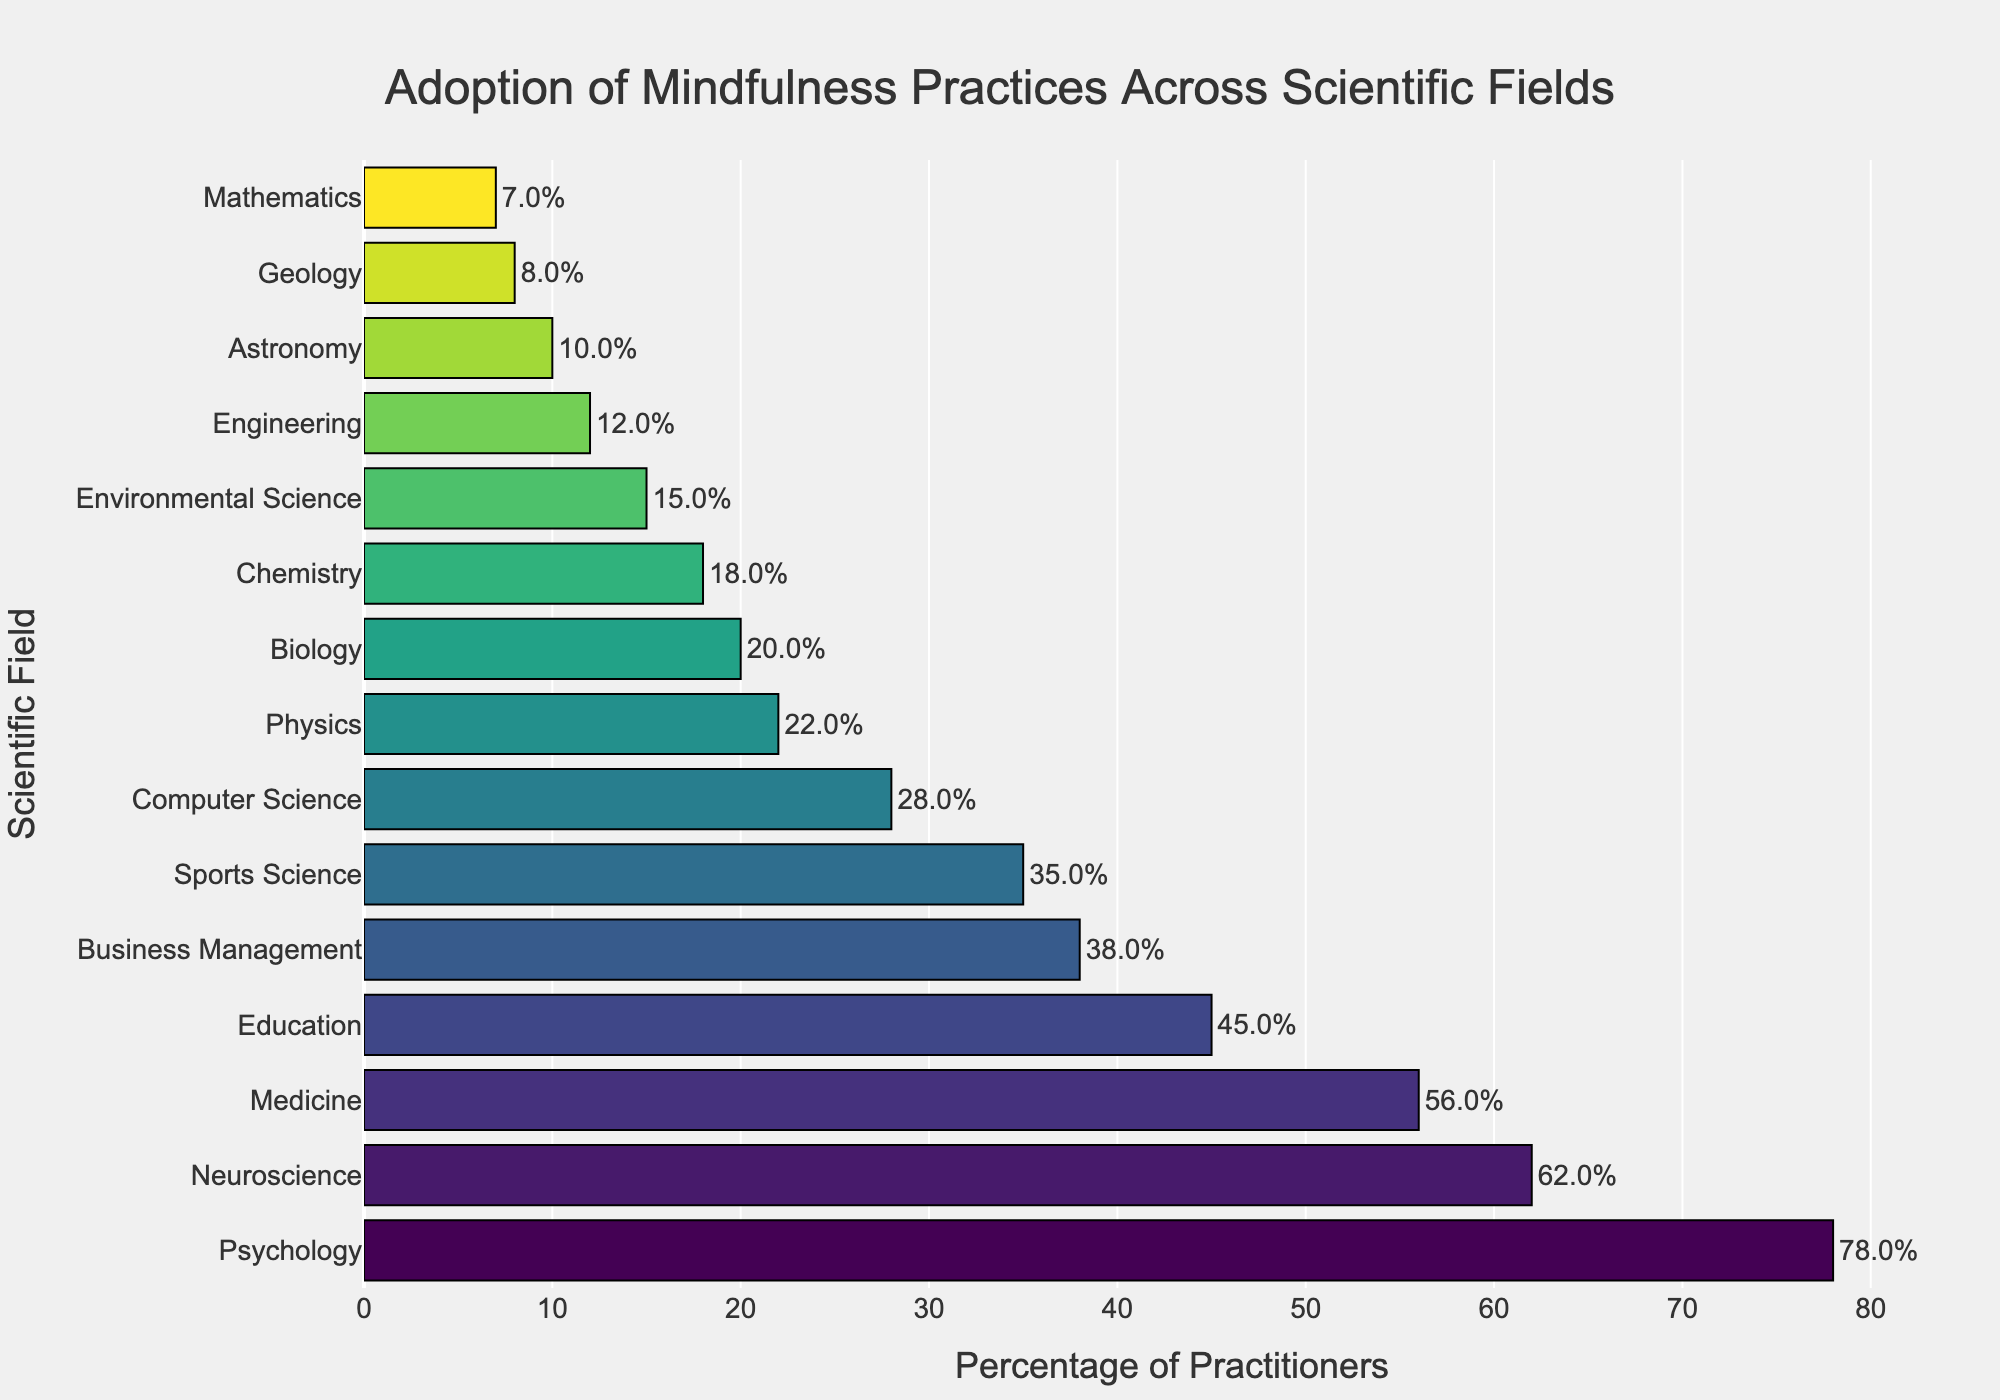Which scientific field has the highest percentage of practitioners adopting mindfulness practices? The field with the tallest bar to the right in the bar chart represents the scientific field with the highest percentage of mindfulness practitioners. In this case, the tallest bar corresponds to Psychology.
Answer: Psychology Which two fields have similar percentages of mindfulness practitioners, according to the bar chart? Fields with bars of almost equal length have similar percentages of practitioners. Sports Science (35%) and Business Management (38%) have similar percentages.
Answer: Sports Science and Business Management How many more practitioners adopt mindfulness in Medicine compared to Engineering? To find the difference, look at the lengths of the bars for Medicine and Engineering. Medicine has 56%, and Engineering has 12%. Subtract Engineering's percentage from Medicine's: 56% - 12%.
Answer: 44% What is the difference in the percentage of practitioners between the field with the highest adoption and the field with the lowest adoption? Identify the highest and lowest bars, which correspond to Psychology (78%) and Mathematics (7%). Subtract the lowest from the highest: 78% - 7%.
Answer: 71% What's the average percentage of practitioners across Psychology, Medicine, and Education? To find the average, sum the percentages and divide by the number of fields. The percentages are Psychology (78%), Medicine (56%), and Education (45%). Calculate the sum: 78 + 56 + 45 = 179, then divide by 3: 179/3.
Answer: 59.67% Between Neuroscience and Computer Science, which field has a lower percentage of mindfulness practitioners? By comparing the lengths of the respective bars for Neuroscience and Computer Science, Neuroscience has 62% and Computer Science has 28%. The shorter bar thus corresponds to Computer Science.
Answer: Computer Science What is the percentage increase in mindfulness practitioners from Chemistry to Physics? Compare the bars for Chemistry (18%) and Physics (22%). Calculate the difference first: 22% - 18% = 4%. Then find the percentage increase relative to Chemistry: (4/18) x 100.
Answer: 22.22% Which field lies exactly in the middle in terms of the percentage of practitioners? With an even number of fields, find the two middle fields by their sorted order. Here, the 7th and 8th fields (Computer Science and Physics) are the middle ones. The average percentage: (28 + 22)/2.
Answer: 25% How many fields have more than 30% adoption of mindfulness practices? Count the bars that extend beyond the 30% mark. Fields that exceed 30% are Psychology, Neuroscience, Medicine, Education, Business Management, and Sports Science. This adds up to six fields.
Answer: 6 fields What is the cumulative percentage of practitioners in the bottom five fields? Identify the bottom five fields: Geology (8%), Mathematics (7%), Astronomy (10%), Engineering (12%), and Environmental Science (15%). Sum these percentages: 8 + 7 + 10 + 12 + 15.
Answer: 52% 